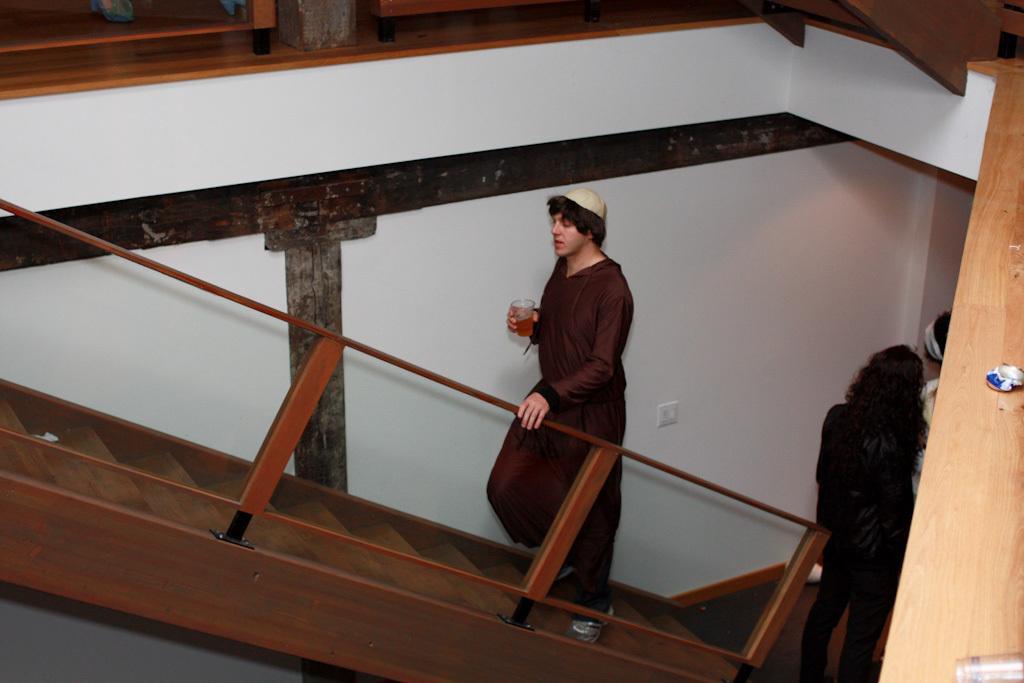In one or two sentences, can you explain what this image depicts? In this image we can see people, steps, wall and rods. One person is holding a glass and climbing the steps. 